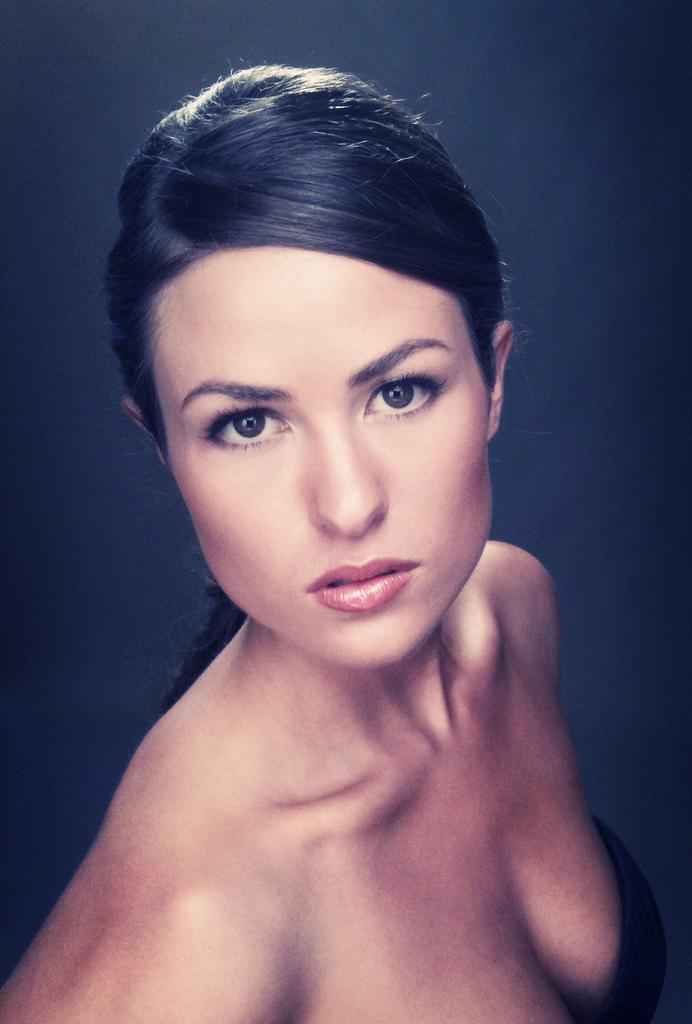What is the main subject of the image? The main subject of the image is a woman. What can be seen in the background of the image? The background of the image is blue in color. What type of button is the queen wearing on her dress in the image? There is no queen or button present in the image; it features a woman in a blue background. 